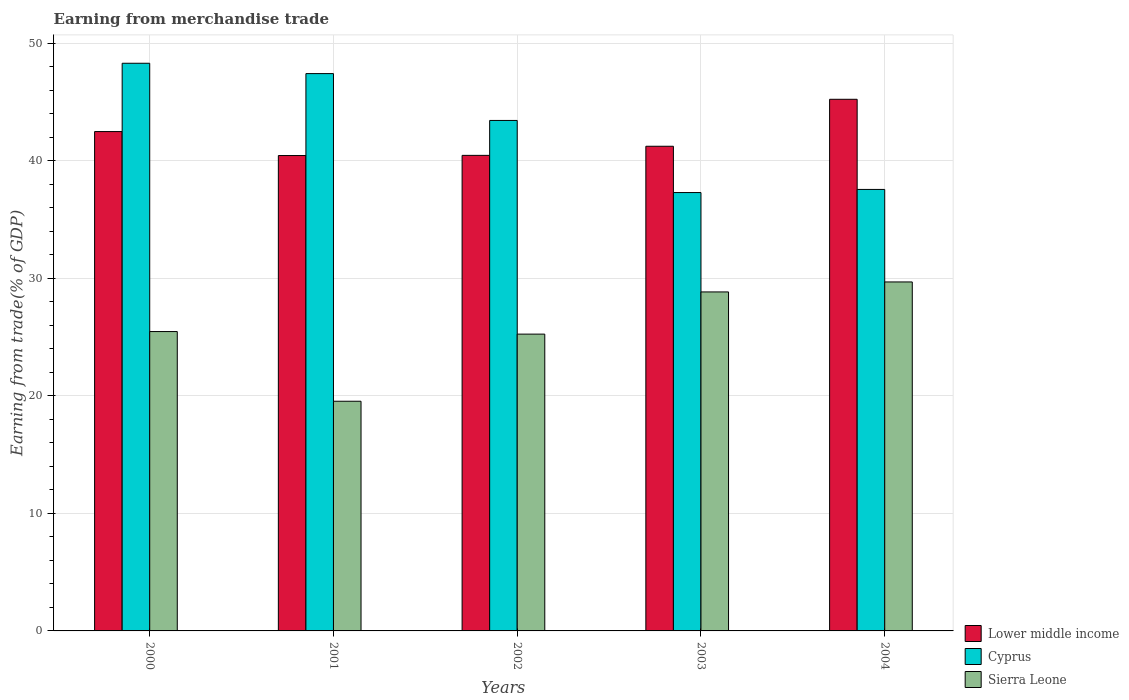How many different coloured bars are there?
Your response must be concise. 3. How many groups of bars are there?
Your response must be concise. 5. Are the number of bars per tick equal to the number of legend labels?
Offer a very short reply. Yes. Are the number of bars on each tick of the X-axis equal?
Offer a very short reply. Yes. How many bars are there on the 4th tick from the left?
Offer a terse response. 3. How many bars are there on the 3rd tick from the right?
Keep it short and to the point. 3. In how many cases, is the number of bars for a given year not equal to the number of legend labels?
Your answer should be very brief. 0. What is the earnings from trade in Cyprus in 2000?
Your response must be concise. 48.31. Across all years, what is the maximum earnings from trade in Lower middle income?
Give a very brief answer. 45.24. Across all years, what is the minimum earnings from trade in Cyprus?
Make the answer very short. 37.31. What is the total earnings from trade in Cyprus in the graph?
Ensure brevity in your answer.  214.06. What is the difference between the earnings from trade in Sierra Leone in 2002 and that in 2003?
Your answer should be compact. -3.59. What is the difference between the earnings from trade in Lower middle income in 2000 and the earnings from trade in Sierra Leone in 2002?
Provide a short and direct response. 17.24. What is the average earnings from trade in Lower middle income per year?
Give a very brief answer. 41.98. In the year 2001, what is the difference between the earnings from trade in Sierra Leone and earnings from trade in Cyprus?
Provide a short and direct response. -27.88. What is the ratio of the earnings from trade in Sierra Leone in 2001 to that in 2002?
Your answer should be very brief. 0.77. Is the earnings from trade in Lower middle income in 2000 less than that in 2003?
Offer a very short reply. No. What is the difference between the highest and the second highest earnings from trade in Lower middle income?
Your answer should be very brief. 2.75. What is the difference between the highest and the lowest earnings from trade in Sierra Leone?
Offer a terse response. 10.15. What does the 1st bar from the left in 2001 represents?
Provide a succinct answer. Lower middle income. What does the 3rd bar from the right in 2002 represents?
Keep it short and to the point. Lower middle income. Is it the case that in every year, the sum of the earnings from trade in Cyprus and earnings from trade in Sierra Leone is greater than the earnings from trade in Lower middle income?
Offer a terse response. Yes. How many years are there in the graph?
Provide a short and direct response. 5. What is the difference between two consecutive major ticks on the Y-axis?
Your answer should be very brief. 10. Does the graph contain grids?
Give a very brief answer. Yes. Where does the legend appear in the graph?
Your answer should be very brief. Bottom right. How are the legend labels stacked?
Your answer should be compact. Vertical. What is the title of the graph?
Offer a terse response. Earning from merchandise trade. What is the label or title of the X-axis?
Your answer should be compact. Years. What is the label or title of the Y-axis?
Offer a very short reply. Earning from trade(% of GDP). What is the Earning from trade(% of GDP) in Lower middle income in 2000?
Ensure brevity in your answer.  42.5. What is the Earning from trade(% of GDP) of Cyprus in 2000?
Your answer should be compact. 48.31. What is the Earning from trade(% of GDP) in Sierra Leone in 2000?
Make the answer very short. 25.48. What is the Earning from trade(% of GDP) in Lower middle income in 2001?
Provide a short and direct response. 40.46. What is the Earning from trade(% of GDP) of Cyprus in 2001?
Make the answer very short. 47.43. What is the Earning from trade(% of GDP) of Sierra Leone in 2001?
Give a very brief answer. 19.55. What is the Earning from trade(% of GDP) in Lower middle income in 2002?
Provide a short and direct response. 40.47. What is the Earning from trade(% of GDP) in Cyprus in 2002?
Provide a short and direct response. 43.44. What is the Earning from trade(% of GDP) in Sierra Leone in 2002?
Offer a very short reply. 25.26. What is the Earning from trade(% of GDP) of Lower middle income in 2003?
Keep it short and to the point. 41.25. What is the Earning from trade(% of GDP) in Cyprus in 2003?
Ensure brevity in your answer.  37.31. What is the Earning from trade(% of GDP) in Sierra Leone in 2003?
Provide a short and direct response. 28.85. What is the Earning from trade(% of GDP) of Lower middle income in 2004?
Offer a terse response. 45.24. What is the Earning from trade(% of GDP) of Cyprus in 2004?
Provide a succinct answer. 37.57. What is the Earning from trade(% of GDP) of Sierra Leone in 2004?
Your answer should be compact. 29.7. Across all years, what is the maximum Earning from trade(% of GDP) in Lower middle income?
Make the answer very short. 45.24. Across all years, what is the maximum Earning from trade(% of GDP) of Cyprus?
Your response must be concise. 48.31. Across all years, what is the maximum Earning from trade(% of GDP) of Sierra Leone?
Your answer should be very brief. 29.7. Across all years, what is the minimum Earning from trade(% of GDP) of Lower middle income?
Make the answer very short. 40.46. Across all years, what is the minimum Earning from trade(% of GDP) of Cyprus?
Your answer should be very brief. 37.31. Across all years, what is the minimum Earning from trade(% of GDP) of Sierra Leone?
Your response must be concise. 19.55. What is the total Earning from trade(% of GDP) of Lower middle income in the graph?
Your answer should be very brief. 209.91. What is the total Earning from trade(% of GDP) of Cyprus in the graph?
Your answer should be very brief. 214.06. What is the total Earning from trade(% of GDP) in Sierra Leone in the graph?
Give a very brief answer. 128.83. What is the difference between the Earning from trade(% of GDP) of Lower middle income in 2000 and that in 2001?
Provide a succinct answer. 2.04. What is the difference between the Earning from trade(% of GDP) of Cyprus in 2000 and that in 2001?
Give a very brief answer. 0.88. What is the difference between the Earning from trade(% of GDP) of Sierra Leone in 2000 and that in 2001?
Give a very brief answer. 5.93. What is the difference between the Earning from trade(% of GDP) in Lower middle income in 2000 and that in 2002?
Offer a very short reply. 2.03. What is the difference between the Earning from trade(% of GDP) in Cyprus in 2000 and that in 2002?
Make the answer very short. 4.87. What is the difference between the Earning from trade(% of GDP) of Sierra Leone in 2000 and that in 2002?
Provide a short and direct response. 0.22. What is the difference between the Earning from trade(% of GDP) of Lower middle income in 2000 and that in 2003?
Offer a very short reply. 1.25. What is the difference between the Earning from trade(% of GDP) of Cyprus in 2000 and that in 2003?
Offer a very short reply. 11. What is the difference between the Earning from trade(% of GDP) of Sierra Leone in 2000 and that in 2003?
Offer a very short reply. -3.37. What is the difference between the Earning from trade(% of GDP) of Lower middle income in 2000 and that in 2004?
Offer a very short reply. -2.75. What is the difference between the Earning from trade(% of GDP) in Cyprus in 2000 and that in 2004?
Give a very brief answer. 10.74. What is the difference between the Earning from trade(% of GDP) of Sierra Leone in 2000 and that in 2004?
Ensure brevity in your answer.  -4.22. What is the difference between the Earning from trade(% of GDP) of Lower middle income in 2001 and that in 2002?
Offer a very short reply. -0.01. What is the difference between the Earning from trade(% of GDP) in Cyprus in 2001 and that in 2002?
Offer a very short reply. 3.99. What is the difference between the Earning from trade(% of GDP) in Sierra Leone in 2001 and that in 2002?
Provide a succinct answer. -5.71. What is the difference between the Earning from trade(% of GDP) in Lower middle income in 2001 and that in 2003?
Keep it short and to the point. -0.79. What is the difference between the Earning from trade(% of GDP) of Cyprus in 2001 and that in 2003?
Your answer should be compact. 10.12. What is the difference between the Earning from trade(% of GDP) in Sierra Leone in 2001 and that in 2003?
Give a very brief answer. -9.3. What is the difference between the Earning from trade(% of GDP) in Lower middle income in 2001 and that in 2004?
Make the answer very short. -4.79. What is the difference between the Earning from trade(% of GDP) of Cyprus in 2001 and that in 2004?
Your answer should be compact. 9.86. What is the difference between the Earning from trade(% of GDP) in Sierra Leone in 2001 and that in 2004?
Keep it short and to the point. -10.15. What is the difference between the Earning from trade(% of GDP) of Lower middle income in 2002 and that in 2003?
Offer a terse response. -0.78. What is the difference between the Earning from trade(% of GDP) of Cyprus in 2002 and that in 2003?
Provide a succinct answer. 6.14. What is the difference between the Earning from trade(% of GDP) in Sierra Leone in 2002 and that in 2003?
Your response must be concise. -3.59. What is the difference between the Earning from trade(% of GDP) of Lower middle income in 2002 and that in 2004?
Make the answer very short. -4.77. What is the difference between the Earning from trade(% of GDP) in Cyprus in 2002 and that in 2004?
Offer a very short reply. 5.87. What is the difference between the Earning from trade(% of GDP) in Sierra Leone in 2002 and that in 2004?
Offer a terse response. -4.44. What is the difference between the Earning from trade(% of GDP) in Lower middle income in 2003 and that in 2004?
Your response must be concise. -4. What is the difference between the Earning from trade(% of GDP) of Cyprus in 2003 and that in 2004?
Your answer should be compact. -0.27. What is the difference between the Earning from trade(% of GDP) of Sierra Leone in 2003 and that in 2004?
Keep it short and to the point. -0.85. What is the difference between the Earning from trade(% of GDP) of Lower middle income in 2000 and the Earning from trade(% of GDP) of Cyprus in 2001?
Keep it short and to the point. -4.93. What is the difference between the Earning from trade(% of GDP) of Lower middle income in 2000 and the Earning from trade(% of GDP) of Sierra Leone in 2001?
Offer a very short reply. 22.95. What is the difference between the Earning from trade(% of GDP) in Cyprus in 2000 and the Earning from trade(% of GDP) in Sierra Leone in 2001?
Give a very brief answer. 28.76. What is the difference between the Earning from trade(% of GDP) of Lower middle income in 2000 and the Earning from trade(% of GDP) of Cyprus in 2002?
Provide a short and direct response. -0.95. What is the difference between the Earning from trade(% of GDP) of Lower middle income in 2000 and the Earning from trade(% of GDP) of Sierra Leone in 2002?
Provide a succinct answer. 17.24. What is the difference between the Earning from trade(% of GDP) of Cyprus in 2000 and the Earning from trade(% of GDP) of Sierra Leone in 2002?
Provide a short and direct response. 23.05. What is the difference between the Earning from trade(% of GDP) in Lower middle income in 2000 and the Earning from trade(% of GDP) in Cyprus in 2003?
Offer a terse response. 5.19. What is the difference between the Earning from trade(% of GDP) of Lower middle income in 2000 and the Earning from trade(% of GDP) of Sierra Leone in 2003?
Offer a very short reply. 13.65. What is the difference between the Earning from trade(% of GDP) of Cyprus in 2000 and the Earning from trade(% of GDP) of Sierra Leone in 2003?
Your answer should be compact. 19.46. What is the difference between the Earning from trade(% of GDP) in Lower middle income in 2000 and the Earning from trade(% of GDP) in Cyprus in 2004?
Keep it short and to the point. 4.92. What is the difference between the Earning from trade(% of GDP) in Lower middle income in 2000 and the Earning from trade(% of GDP) in Sierra Leone in 2004?
Provide a short and direct response. 12.8. What is the difference between the Earning from trade(% of GDP) in Cyprus in 2000 and the Earning from trade(% of GDP) in Sierra Leone in 2004?
Provide a short and direct response. 18.61. What is the difference between the Earning from trade(% of GDP) of Lower middle income in 2001 and the Earning from trade(% of GDP) of Cyprus in 2002?
Give a very brief answer. -2.99. What is the difference between the Earning from trade(% of GDP) in Lower middle income in 2001 and the Earning from trade(% of GDP) in Sierra Leone in 2002?
Your answer should be very brief. 15.2. What is the difference between the Earning from trade(% of GDP) of Cyprus in 2001 and the Earning from trade(% of GDP) of Sierra Leone in 2002?
Provide a short and direct response. 22.17. What is the difference between the Earning from trade(% of GDP) in Lower middle income in 2001 and the Earning from trade(% of GDP) in Cyprus in 2003?
Your answer should be very brief. 3.15. What is the difference between the Earning from trade(% of GDP) of Lower middle income in 2001 and the Earning from trade(% of GDP) of Sierra Leone in 2003?
Offer a terse response. 11.61. What is the difference between the Earning from trade(% of GDP) of Cyprus in 2001 and the Earning from trade(% of GDP) of Sierra Leone in 2003?
Offer a very short reply. 18.58. What is the difference between the Earning from trade(% of GDP) of Lower middle income in 2001 and the Earning from trade(% of GDP) of Cyprus in 2004?
Ensure brevity in your answer.  2.88. What is the difference between the Earning from trade(% of GDP) in Lower middle income in 2001 and the Earning from trade(% of GDP) in Sierra Leone in 2004?
Make the answer very short. 10.76. What is the difference between the Earning from trade(% of GDP) in Cyprus in 2001 and the Earning from trade(% of GDP) in Sierra Leone in 2004?
Offer a terse response. 17.73. What is the difference between the Earning from trade(% of GDP) of Lower middle income in 2002 and the Earning from trade(% of GDP) of Cyprus in 2003?
Your response must be concise. 3.16. What is the difference between the Earning from trade(% of GDP) in Lower middle income in 2002 and the Earning from trade(% of GDP) in Sierra Leone in 2003?
Your answer should be very brief. 11.62. What is the difference between the Earning from trade(% of GDP) in Cyprus in 2002 and the Earning from trade(% of GDP) in Sierra Leone in 2003?
Give a very brief answer. 14.59. What is the difference between the Earning from trade(% of GDP) of Lower middle income in 2002 and the Earning from trade(% of GDP) of Cyprus in 2004?
Your answer should be compact. 2.9. What is the difference between the Earning from trade(% of GDP) of Lower middle income in 2002 and the Earning from trade(% of GDP) of Sierra Leone in 2004?
Offer a terse response. 10.77. What is the difference between the Earning from trade(% of GDP) of Cyprus in 2002 and the Earning from trade(% of GDP) of Sierra Leone in 2004?
Provide a short and direct response. 13.74. What is the difference between the Earning from trade(% of GDP) in Lower middle income in 2003 and the Earning from trade(% of GDP) in Cyprus in 2004?
Offer a very short reply. 3.67. What is the difference between the Earning from trade(% of GDP) in Lower middle income in 2003 and the Earning from trade(% of GDP) in Sierra Leone in 2004?
Offer a very short reply. 11.55. What is the difference between the Earning from trade(% of GDP) of Cyprus in 2003 and the Earning from trade(% of GDP) of Sierra Leone in 2004?
Your answer should be compact. 7.61. What is the average Earning from trade(% of GDP) in Lower middle income per year?
Provide a short and direct response. 41.98. What is the average Earning from trade(% of GDP) in Cyprus per year?
Your answer should be very brief. 42.81. What is the average Earning from trade(% of GDP) of Sierra Leone per year?
Keep it short and to the point. 25.77. In the year 2000, what is the difference between the Earning from trade(% of GDP) in Lower middle income and Earning from trade(% of GDP) in Cyprus?
Your answer should be very brief. -5.81. In the year 2000, what is the difference between the Earning from trade(% of GDP) of Lower middle income and Earning from trade(% of GDP) of Sierra Leone?
Provide a short and direct response. 17.02. In the year 2000, what is the difference between the Earning from trade(% of GDP) in Cyprus and Earning from trade(% of GDP) in Sierra Leone?
Your answer should be very brief. 22.83. In the year 2001, what is the difference between the Earning from trade(% of GDP) in Lower middle income and Earning from trade(% of GDP) in Cyprus?
Your response must be concise. -6.97. In the year 2001, what is the difference between the Earning from trade(% of GDP) in Lower middle income and Earning from trade(% of GDP) in Sierra Leone?
Provide a short and direct response. 20.91. In the year 2001, what is the difference between the Earning from trade(% of GDP) of Cyprus and Earning from trade(% of GDP) of Sierra Leone?
Make the answer very short. 27.88. In the year 2002, what is the difference between the Earning from trade(% of GDP) in Lower middle income and Earning from trade(% of GDP) in Cyprus?
Ensure brevity in your answer.  -2.97. In the year 2002, what is the difference between the Earning from trade(% of GDP) of Lower middle income and Earning from trade(% of GDP) of Sierra Leone?
Make the answer very short. 15.21. In the year 2002, what is the difference between the Earning from trade(% of GDP) of Cyprus and Earning from trade(% of GDP) of Sierra Leone?
Provide a succinct answer. 18.19. In the year 2003, what is the difference between the Earning from trade(% of GDP) in Lower middle income and Earning from trade(% of GDP) in Cyprus?
Make the answer very short. 3.94. In the year 2003, what is the difference between the Earning from trade(% of GDP) of Lower middle income and Earning from trade(% of GDP) of Sierra Leone?
Offer a terse response. 12.4. In the year 2003, what is the difference between the Earning from trade(% of GDP) in Cyprus and Earning from trade(% of GDP) in Sierra Leone?
Offer a very short reply. 8.46. In the year 2004, what is the difference between the Earning from trade(% of GDP) in Lower middle income and Earning from trade(% of GDP) in Cyprus?
Offer a terse response. 7.67. In the year 2004, what is the difference between the Earning from trade(% of GDP) in Lower middle income and Earning from trade(% of GDP) in Sierra Leone?
Your answer should be compact. 15.54. In the year 2004, what is the difference between the Earning from trade(% of GDP) in Cyprus and Earning from trade(% of GDP) in Sierra Leone?
Offer a very short reply. 7.87. What is the ratio of the Earning from trade(% of GDP) of Lower middle income in 2000 to that in 2001?
Provide a short and direct response. 1.05. What is the ratio of the Earning from trade(% of GDP) in Cyprus in 2000 to that in 2001?
Provide a succinct answer. 1.02. What is the ratio of the Earning from trade(% of GDP) of Sierra Leone in 2000 to that in 2001?
Your response must be concise. 1.3. What is the ratio of the Earning from trade(% of GDP) of Cyprus in 2000 to that in 2002?
Your answer should be compact. 1.11. What is the ratio of the Earning from trade(% of GDP) of Sierra Leone in 2000 to that in 2002?
Offer a very short reply. 1.01. What is the ratio of the Earning from trade(% of GDP) in Lower middle income in 2000 to that in 2003?
Your answer should be compact. 1.03. What is the ratio of the Earning from trade(% of GDP) in Cyprus in 2000 to that in 2003?
Give a very brief answer. 1.29. What is the ratio of the Earning from trade(% of GDP) in Sierra Leone in 2000 to that in 2003?
Keep it short and to the point. 0.88. What is the ratio of the Earning from trade(% of GDP) in Lower middle income in 2000 to that in 2004?
Your response must be concise. 0.94. What is the ratio of the Earning from trade(% of GDP) of Cyprus in 2000 to that in 2004?
Your answer should be compact. 1.29. What is the ratio of the Earning from trade(% of GDP) of Sierra Leone in 2000 to that in 2004?
Give a very brief answer. 0.86. What is the ratio of the Earning from trade(% of GDP) of Cyprus in 2001 to that in 2002?
Ensure brevity in your answer.  1.09. What is the ratio of the Earning from trade(% of GDP) of Sierra Leone in 2001 to that in 2002?
Give a very brief answer. 0.77. What is the ratio of the Earning from trade(% of GDP) of Lower middle income in 2001 to that in 2003?
Make the answer very short. 0.98. What is the ratio of the Earning from trade(% of GDP) of Cyprus in 2001 to that in 2003?
Your answer should be compact. 1.27. What is the ratio of the Earning from trade(% of GDP) of Sierra Leone in 2001 to that in 2003?
Ensure brevity in your answer.  0.68. What is the ratio of the Earning from trade(% of GDP) in Lower middle income in 2001 to that in 2004?
Your answer should be compact. 0.89. What is the ratio of the Earning from trade(% of GDP) of Cyprus in 2001 to that in 2004?
Your answer should be very brief. 1.26. What is the ratio of the Earning from trade(% of GDP) of Sierra Leone in 2001 to that in 2004?
Provide a short and direct response. 0.66. What is the ratio of the Earning from trade(% of GDP) of Lower middle income in 2002 to that in 2003?
Provide a short and direct response. 0.98. What is the ratio of the Earning from trade(% of GDP) in Cyprus in 2002 to that in 2003?
Provide a succinct answer. 1.16. What is the ratio of the Earning from trade(% of GDP) in Sierra Leone in 2002 to that in 2003?
Make the answer very short. 0.88. What is the ratio of the Earning from trade(% of GDP) in Lower middle income in 2002 to that in 2004?
Give a very brief answer. 0.89. What is the ratio of the Earning from trade(% of GDP) of Cyprus in 2002 to that in 2004?
Provide a short and direct response. 1.16. What is the ratio of the Earning from trade(% of GDP) in Sierra Leone in 2002 to that in 2004?
Provide a short and direct response. 0.85. What is the ratio of the Earning from trade(% of GDP) of Lower middle income in 2003 to that in 2004?
Ensure brevity in your answer.  0.91. What is the ratio of the Earning from trade(% of GDP) of Cyprus in 2003 to that in 2004?
Make the answer very short. 0.99. What is the ratio of the Earning from trade(% of GDP) in Sierra Leone in 2003 to that in 2004?
Keep it short and to the point. 0.97. What is the difference between the highest and the second highest Earning from trade(% of GDP) in Lower middle income?
Give a very brief answer. 2.75. What is the difference between the highest and the second highest Earning from trade(% of GDP) of Cyprus?
Ensure brevity in your answer.  0.88. What is the difference between the highest and the second highest Earning from trade(% of GDP) of Sierra Leone?
Make the answer very short. 0.85. What is the difference between the highest and the lowest Earning from trade(% of GDP) in Lower middle income?
Provide a succinct answer. 4.79. What is the difference between the highest and the lowest Earning from trade(% of GDP) of Cyprus?
Give a very brief answer. 11. What is the difference between the highest and the lowest Earning from trade(% of GDP) in Sierra Leone?
Your response must be concise. 10.15. 